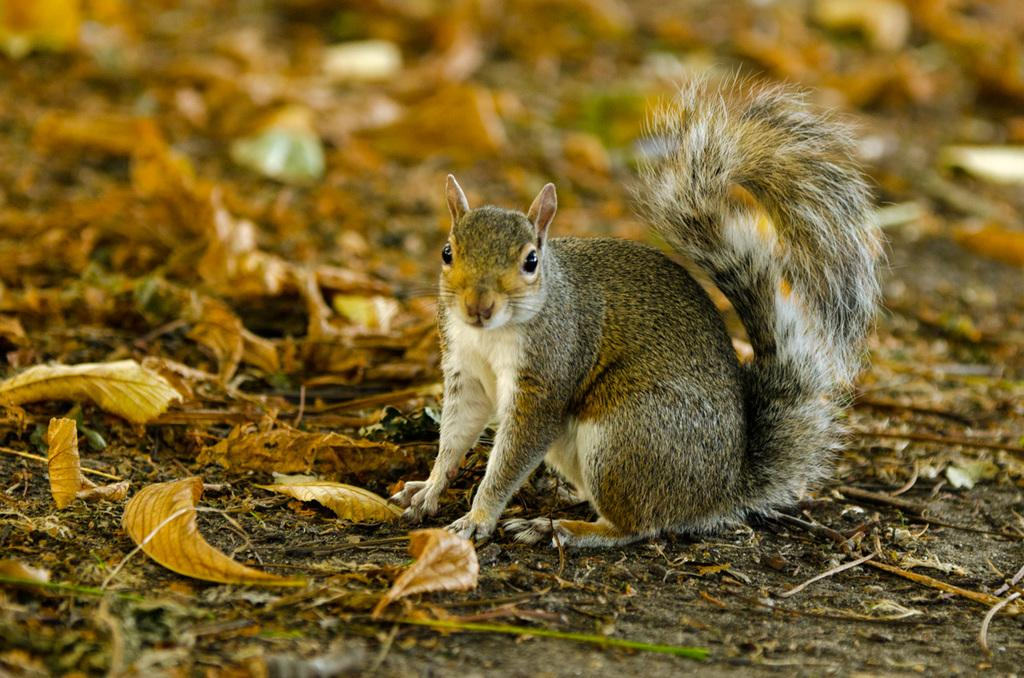What is the main subject in the center of the image? There is a squirrel in the center of the image. What type of vegetation can be seen in the image? Dry leaves are present in the image. Can you describe the background of the image? The background of the image is blurred. How many cats are playing with the squirrel in the image? There are no cats present in the image; it features a squirrel and dry leaves. What is the reason for the squirrel's behavior in the image? The image does not provide any information about the squirrel's behavior or the reason behind it. 